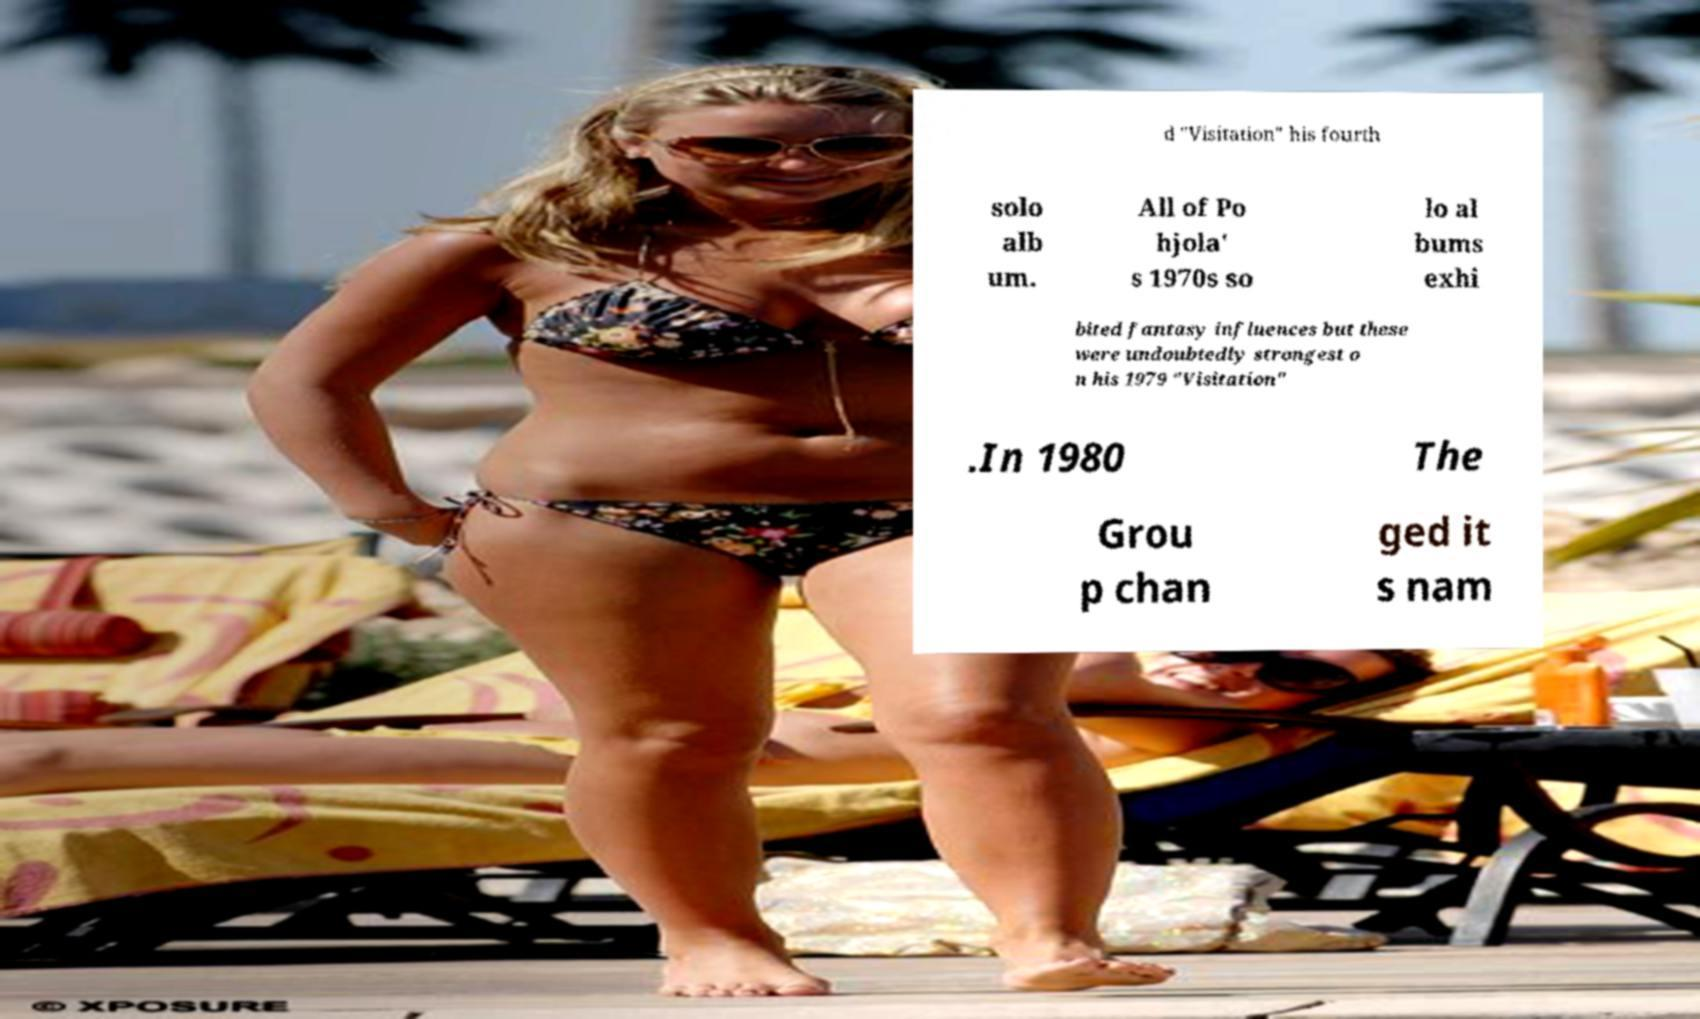There's text embedded in this image that I need extracted. Can you transcribe it verbatim? d "Visitation" his fourth solo alb um. All of Po hjola' s 1970s so lo al bums exhi bited fantasy influences but these were undoubtedly strongest o n his 1979 "Visitation" .In 1980 The Grou p chan ged it s nam 